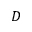<formula> <loc_0><loc_0><loc_500><loc_500>D</formula> 